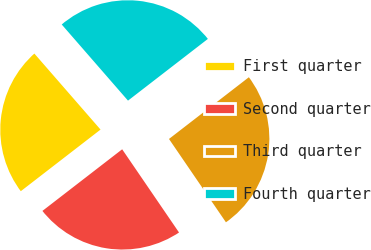Convert chart. <chart><loc_0><loc_0><loc_500><loc_500><pie_chart><fcel>First quarter<fcel>Second quarter<fcel>Third quarter<fcel>Fourth quarter<nl><fcel>24.07%<fcel>24.07%<fcel>25.93%<fcel>25.93%<nl></chart> 